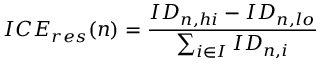Convert formula to latex. <formula><loc_0><loc_0><loc_500><loc_500>I C E _ { r e s } ( n ) = \frac { I D _ { n , h i } - I D _ { n , l o } } { \sum _ { i \in I } I D _ { n , i } }</formula> 